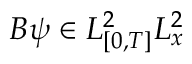<formula> <loc_0><loc_0><loc_500><loc_500>B \psi \in L _ { [ 0 , T ] } ^ { 2 } L _ { x } ^ { 2 }</formula> 